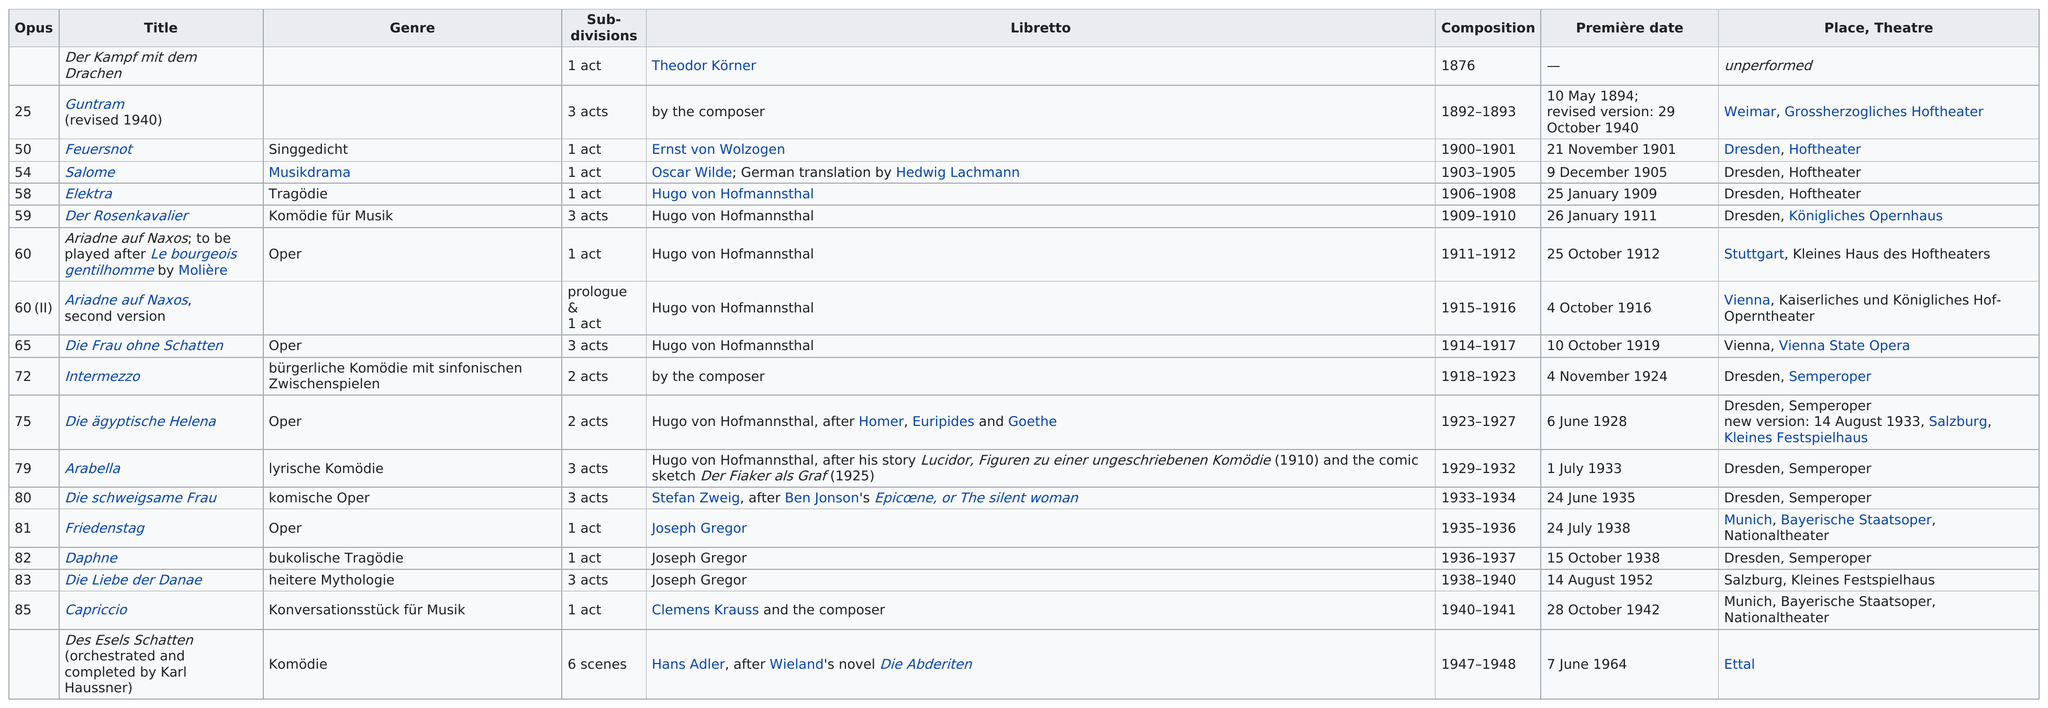Indicate a few pertinent items in this graphic. Nine operas had their premieres in Dresden. The title after 'Feuersnot' is 'Salome,' In total, 9 operas were performed at the Dresden Opera House. Des Esels Schatten is the only opera that is not divided into acts. Of the listed compositions, 8 included at least 2 acts. 